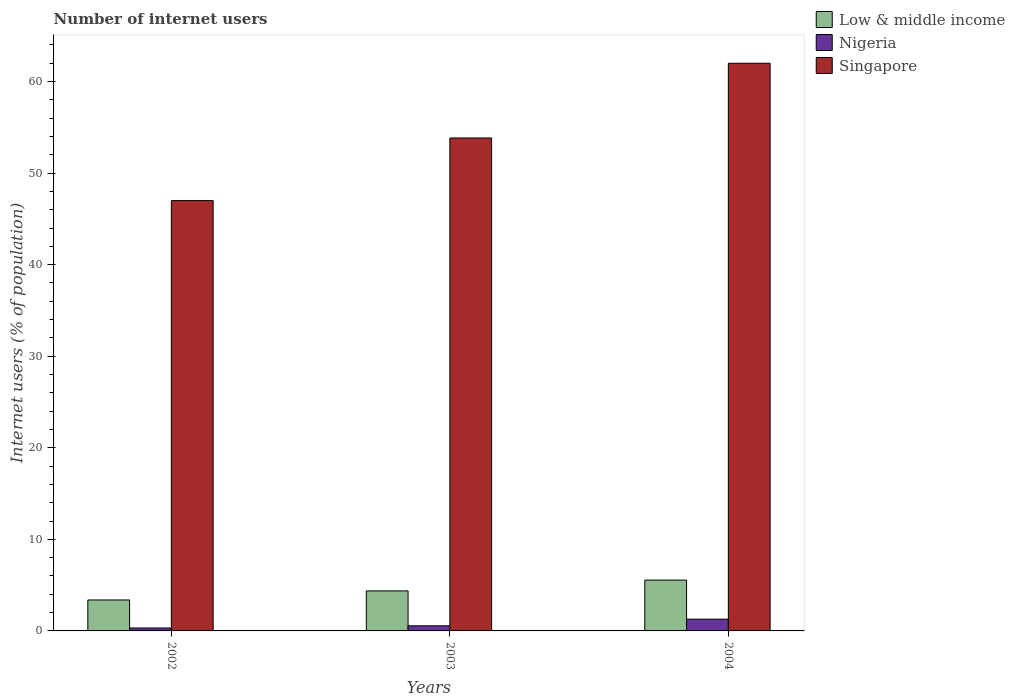How many different coloured bars are there?
Give a very brief answer. 3. What is the label of the 2nd group of bars from the left?
Your response must be concise. 2003. What is the total number of internet users in Singapore in the graph?
Your response must be concise. 162.84. What is the difference between the number of internet users in Nigeria in 2002 and the number of internet users in Singapore in 2004?
Provide a short and direct response. -61.68. What is the average number of internet users in Low & middle income per year?
Keep it short and to the point. 4.44. In the year 2002, what is the difference between the number of internet users in Singapore and number of internet users in Nigeria?
Provide a succinct answer. 46.68. What is the ratio of the number of internet users in Singapore in 2003 to that in 2004?
Provide a succinct answer. 0.87. Is the number of internet users in Low & middle income in 2002 less than that in 2003?
Your response must be concise. Yes. Is the difference between the number of internet users in Singapore in 2002 and 2003 greater than the difference between the number of internet users in Nigeria in 2002 and 2003?
Offer a very short reply. No. What is the difference between the highest and the second highest number of internet users in Nigeria?
Provide a short and direct response. 0.73. What is the difference between the highest and the lowest number of internet users in Nigeria?
Ensure brevity in your answer.  0.97. Is the sum of the number of internet users in Nigeria in 2002 and 2004 greater than the maximum number of internet users in Singapore across all years?
Provide a short and direct response. No. What does the 2nd bar from the left in 2004 represents?
Make the answer very short. Nigeria. What does the 1st bar from the right in 2003 represents?
Your answer should be compact. Singapore. How many bars are there?
Your response must be concise. 9. Are all the bars in the graph horizontal?
Your answer should be compact. No. Does the graph contain grids?
Your response must be concise. No. What is the title of the graph?
Offer a terse response. Number of internet users. What is the label or title of the X-axis?
Offer a terse response. Years. What is the label or title of the Y-axis?
Offer a very short reply. Internet users (% of population). What is the Internet users (% of population) of Low & middle income in 2002?
Ensure brevity in your answer.  3.38. What is the Internet users (% of population) in Nigeria in 2002?
Provide a short and direct response. 0.32. What is the Internet users (% of population) of Singapore in 2002?
Your response must be concise. 47. What is the Internet users (% of population) in Low & middle income in 2003?
Provide a short and direct response. 4.37. What is the Internet users (% of population) in Nigeria in 2003?
Keep it short and to the point. 0.56. What is the Internet users (% of population) of Singapore in 2003?
Give a very brief answer. 53.84. What is the Internet users (% of population) in Low & middle income in 2004?
Offer a terse response. 5.55. What is the Internet users (% of population) of Nigeria in 2004?
Give a very brief answer. 1.29. Across all years, what is the maximum Internet users (% of population) in Low & middle income?
Make the answer very short. 5.55. Across all years, what is the maximum Internet users (% of population) of Nigeria?
Offer a terse response. 1.29. Across all years, what is the minimum Internet users (% of population) of Low & middle income?
Keep it short and to the point. 3.38. Across all years, what is the minimum Internet users (% of population) in Nigeria?
Your answer should be very brief. 0.32. What is the total Internet users (% of population) of Low & middle income in the graph?
Your answer should be compact. 13.31. What is the total Internet users (% of population) of Nigeria in the graph?
Your answer should be very brief. 2.17. What is the total Internet users (% of population) in Singapore in the graph?
Offer a terse response. 162.84. What is the difference between the Internet users (% of population) in Low & middle income in 2002 and that in 2003?
Offer a terse response. -0.99. What is the difference between the Internet users (% of population) in Nigeria in 2002 and that in 2003?
Keep it short and to the point. -0.24. What is the difference between the Internet users (% of population) in Singapore in 2002 and that in 2003?
Make the answer very short. -6.84. What is the difference between the Internet users (% of population) in Low & middle income in 2002 and that in 2004?
Your answer should be compact. -2.17. What is the difference between the Internet users (% of population) of Nigeria in 2002 and that in 2004?
Offer a very short reply. -0.97. What is the difference between the Internet users (% of population) of Low & middle income in 2003 and that in 2004?
Ensure brevity in your answer.  -1.18. What is the difference between the Internet users (% of population) of Nigeria in 2003 and that in 2004?
Offer a very short reply. -0.73. What is the difference between the Internet users (% of population) in Singapore in 2003 and that in 2004?
Ensure brevity in your answer.  -8.16. What is the difference between the Internet users (% of population) of Low & middle income in 2002 and the Internet users (% of population) of Nigeria in 2003?
Provide a succinct answer. 2.82. What is the difference between the Internet users (% of population) in Low & middle income in 2002 and the Internet users (% of population) in Singapore in 2003?
Make the answer very short. -50.46. What is the difference between the Internet users (% of population) in Nigeria in 2002 and the Internet users (% of population) in Singapore in 2003?
Your response must be concise. -53.52. What is the difference between the Internet users (% of population) in Low & middle income in 2002 and the Internet users (% of population) in Nigeria in 2004?
Your response must be concise. 2.1. What is the difference between the Internet users (% of population) of Low & middle income in 2002 and the Internet users (% of population) of Singapore in 2004?
Your answer should be very brief. -58.62. What is the difference between the Internet users (% of population) in Nigeria in 2002 and the Internet users (% of population) in Singapore in 2004?
Ensure brevity in your answer.  -61.68. What is the difference between the Internet users (% of population) in Low & middle income in 2003 and the Internet users (% of population) in Nigeria in 2004?
Give a very brief answer. 3.09. What is the difference between the Internet users (% of population) of Low & middle income in 2003 and the Internet users (% of population) of Singapore in 2004?
Your answer should be very brief. -57.63. What is the difference between the Internet users (% of population) of Nigeria in 2003 and the Internet users (% of population) of Singapore in 2004?
Offer a terse response. -61.44. What is the average Internet users (% of population) in Low & middle income per year?
Offer a terse response. 4.43. What is the average Internet users (% of population) of Nigeria per year?
Provide a succinct answer. 0.72. What is the average Internet users (% of population) in Singapore per year?
Provide a succinct answer. 54.28. In the year 2002, what is the difference between the Internet users (% of population) of Low & middle income and Internet users (% of population) of Nigeria?
Ensure brevity in your answer.  3.06. In the year 2002, what is the difference between the Internet users (% of population) in Low & middle income and Internet users (% of population) in Singapore?
Your answer should be compact. -43.62. In the year 2002, what is the difference between the Internet users (% of population) of Nigeria and Internet users (% of population) of Singapore?
Provide a succinct answer. -46.68. In the year 2003, what is the difference between the Internet users (% of population) of Low & middle income and Internet users (% of population) of Nigeria?
Your answer should be very brief. 3.81. In the year 2003, what is the difference between the Internet users (% of population) of Low & middle income and Internet users (% of population) of Singapore?
Keep it short and to the point. -49.47. In the year 2003, what is the difference between the Internet users (% of population) of Nigeria and Internet users (% of population) of Singapore?
Your answer should be very brief. -53.28. In the year 2004, what is the difference between the Internet users (% of population) in Low & middle income and Internet users (% of population) in Nigeria?
Offer a very short reply. 4.27. In the year 2004, what is the difference between the Internet users (% of population) of Low & middle income and Internet users (% of population) of Singapore?
Make the answer very short. -56.45. In the year 2004, what is the difference between the Internet users (% of population) in Nigeria and Internet users (% of population) in Singapore?
Provide a short and direct response. -60.71. What is the ratio of the Internet users (% of population) in Low & middle income in 2002 to that in 2003?
Provide a short and direct response. 0.77. What is the ratio of the Internet users (% of population) of Nigeria in 2002 to that in 2003?
Provide a short and direct response. 0.57. What is the ratio of the Internet users (% of population) of Singapore in 2002 to that in 2003?
Your response must be concise. 0.87. What is the ratio of the Internet users (% of population) of Low & middle income in 2002 to that in 2004?
Make the answer very short. 0.61. What is the ratio of the Internet users (% of population) in Nigeria in 2002 to that in 2004?
Provide a succinct answer. 0.25. What is the ratio of the Internet users (% of population) in Singapore in 2002 to that in 2004?
Your answer should be very brief. 0.76. What is the ratio of the Internet users (% of population) of Low & middle income in 2003 to that in 2004?
Provide a short and direct response. 0.79. What is the ratio of the Internet users (% of population) in Nigeria in 2003 to that in 2004?
Your response must be concise. 0.43. What is the ratio of the Internet users (% of population) of Singapore in 2003 to that in 2004?
Your answer should be very brief. 0.87. What is the difference between the highest and the second highest Internet users (% of population) of Low & middle income?
Your answer should be compact. 1.18. What is the difference between the highest and the second highest Internet users (% of population) of Nigeria?
Your response must be concise. 0.73. What is the difference between the highest and the second highest Internet users (% of population) in Singapore?
Your answer should be very brief. 8.16. What is the difference between the highest and the lowest Internet users (% of population) in Low & middle income?
Your response must be concise. 2.17. What is the difference between the highest and the lowest Internet users (% of population) in Nigeria?
Your answer should be very brief. 0.97. 